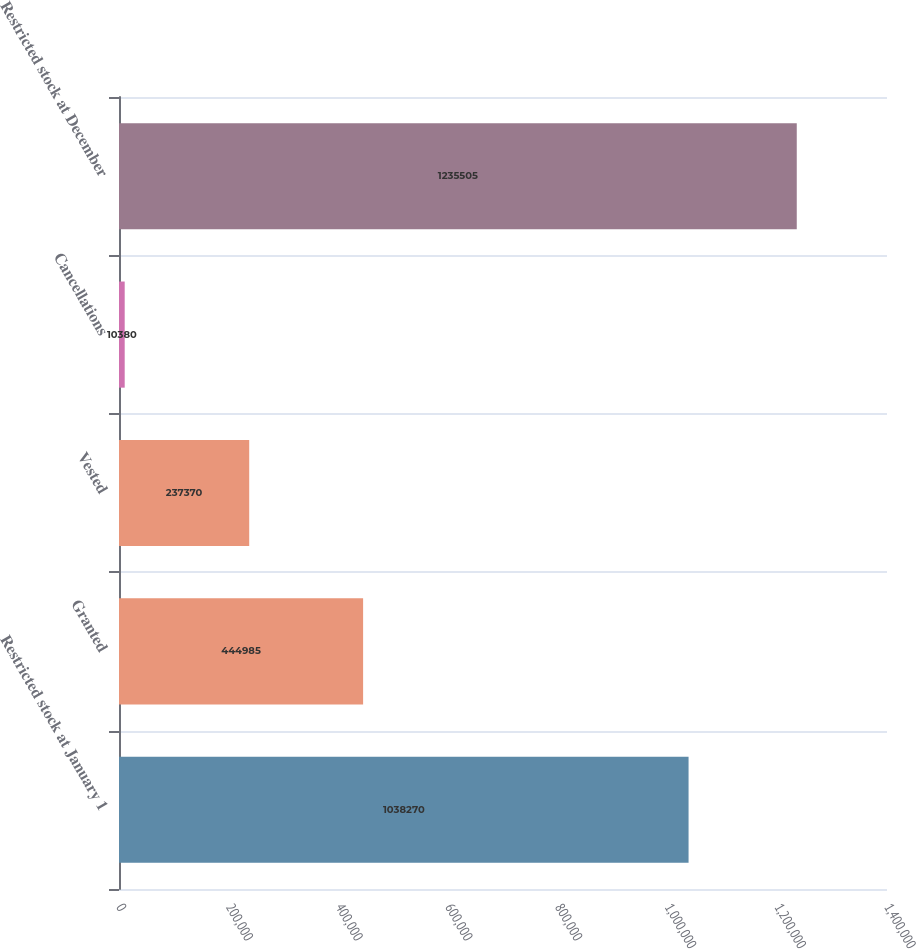Convert chart. <chart><loc_0><loc_0><loc_500><loc_500><bar_chart><fcel>Restricted stock at January 1<fcel>Granted<fcel>Vested<fcel>Cancellations<fcel>Restricted stock at December<nl><fcel>1.03827e+06<fcel>444985<fcel>237370<fcel>10380<fcel>1.2355e+06<nl></chart> 